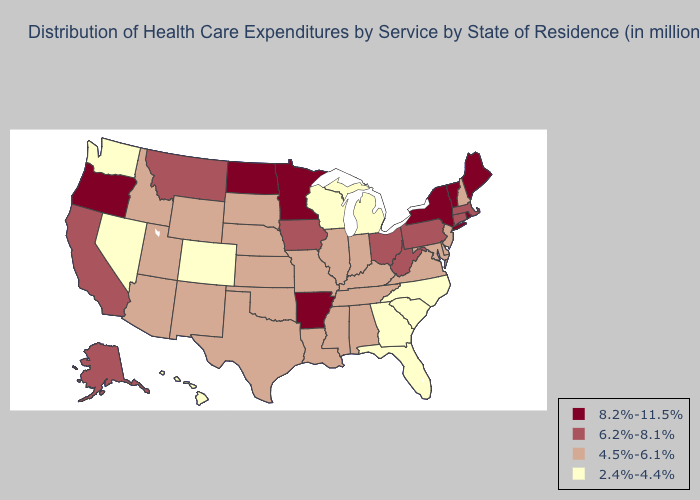Among the states that border Nebraska , does Iowa have the highest value?
Concise answer only. Yes. Which states have the highest value in the USA?
Concise answer only. Arkansas, Maine, Minnesota, New York, North Dakota, Oregon, Rhode Island, Vermont. Which states hav the highest value in the West?
Keep it brief. Oregon. Does Maryland have the highest value in the South?
Keep it brief. No. Is the legend a continuous bar?
Give a very brief answer. No. Name the states that have a value in the range 2.4%-4.4%?
Short answer required. Colorado, Florida, Georgia, Hawaii, Michigan, Nevada, North Carolina, South Carolina, Washington, Wisconsin. Among the states that border Wisconsin , does Minnesota have the highest value?
Give a very brief answer. Yes. Name the states that have a value in the range 4.5%-6.1%?
Answer briefly. Alabama, Arizona, Delaware, Idaho, Illinois, Indiana, Kansas, Kentucky, Louisiana, Maryland, Mississippi, Missouri, Nebraska, New Hampshire, New Jersey, New Mexico, Oklahoma, South Dakota, Tennessee, Texas, Utah, Virginia, Wyoming. Does the first symbol in the legend represent the smallest category?
Keep it brief. No. What is the highest value in the USA?
Answer briefly. 8.2%-11.5%. Name the states that have a value in the range 8.2%-11.5%?
Write a very short answer. Arkansas, Maine, Minnesota, New York, North Dakota, Oregon, Rhode Island, Vermont. What is the highest value in the USA?
Keep it brief. 8.2%-11.5%. Does Virginia have the lowest value in the USA?
Keep it brief. No. Does Arkansas have the highest value in the South?
Quick response, please. Yes. What is the value of Kansas?
Answer briefly. 4.5%-6.1%. 